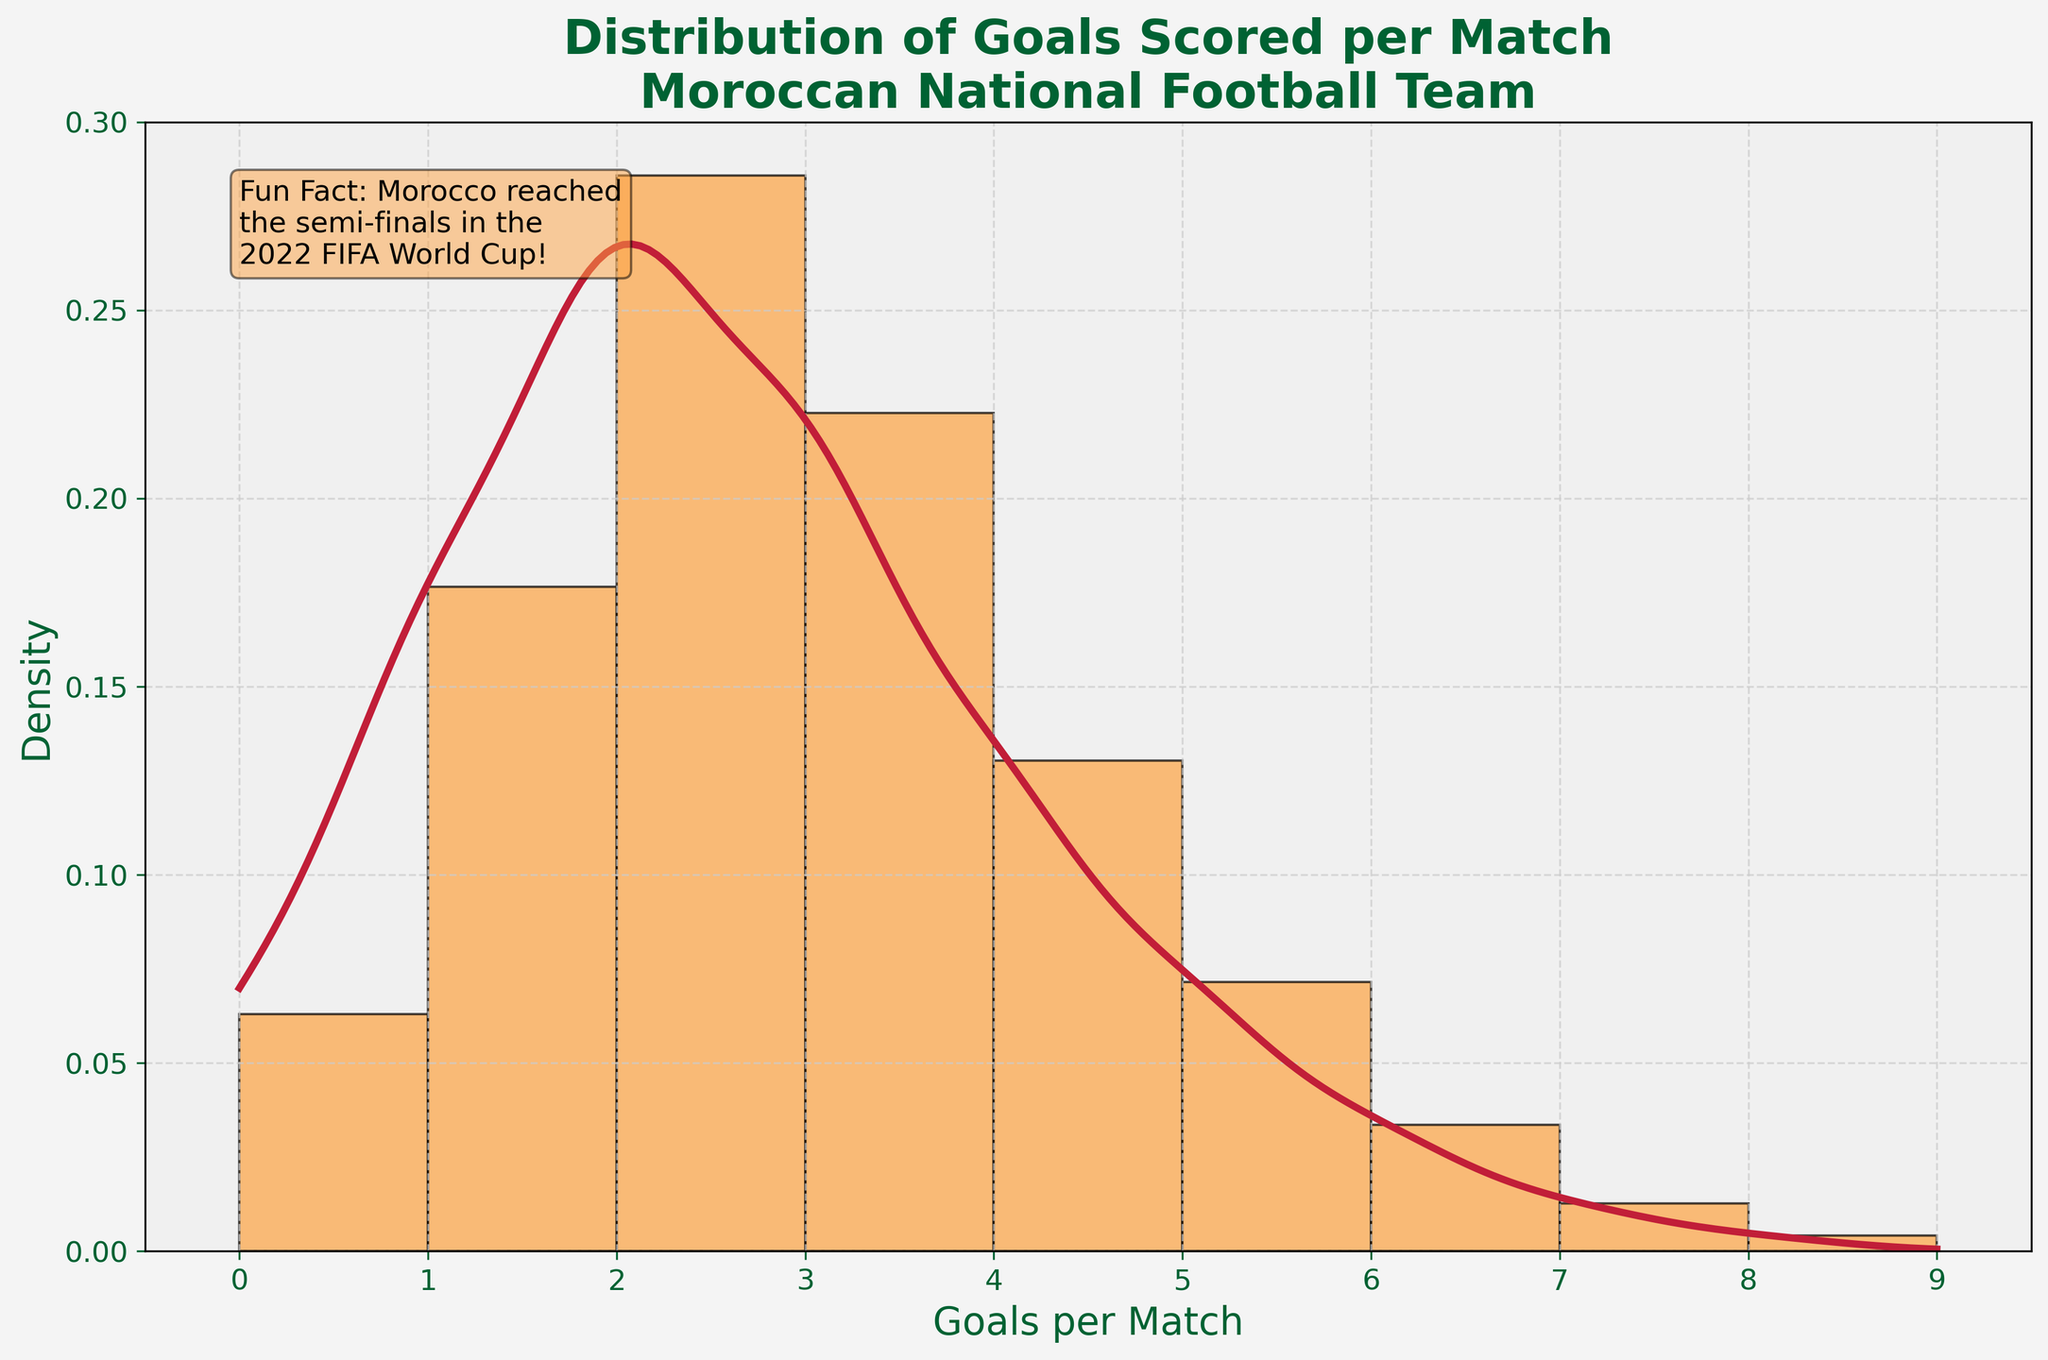What is the title of the histogram? The title of the histogram is prominently displayed at the top and reads 'Distribution of Goals Scored per Match\nMoroccan National Football Team'.
Answer: Distribution of Goals Scored per Match Moroccan National Football Team What does the x-axis represent? The x-axis labels on the horizontal line indicate the number of goals scored per match.
Answer: Goals per Match What does the y-axis represent? The y-axis labels on the vertical line indicate the density, showing the frequency of occurrences of goals scored per match in the Moroccan national football team's history.
Answer: Density Which number of goals scored per match is the most frequent? The highest bar in the histogram represents the most frequent number of goals scored per match. It corresponds to the value 2 on the x-axis.
Answer: 2 What can you infer about matches where Morocco scored 8 goals? The histogram's bar height for 8 goals per match is quite low compared to other bars, indicating that scoring 8 goals in a match is very rare for the Moroccan team.
Answer: Rare How many goals are most common for Morocco to score in a match based on the KDE curve? The peak of the KDE curve shows the highest density around 2 goals, indicating that 2 goals per match is the most common.
Answer: 2 Are matches where Morocco scored no goals more frequent than matches where they scored 5 goals? By comparing the heights of the histogram bars at 0 and 5 goals, we see that the bar at 0 is higher than the bar at 5 goals, indicating matches with no goals are more frequent.
Answer: Yes What's the total number of matches included in this histogram? Adding up all the frequencies from each bar will give the total number of matches: 15 + 42 + 68 + 53 + 31 + 17 + 8 + 3 + 1 = 238.
Answer: 238 In how many matches did Morocco score more than 4 goals? Summing the frequencies for goals greater than 4 (5, 6, 7, 8): 17 + 8 + 3 + 1 = 29.
Answer: 29 What is the overall trend of goal-scoring frequency as the number of goals increases? The histogram shows that as the number of goals increases, the frequency generally decreases, with the highest frequency at 2 goals and tapering off gradually.
Answer: Decreasing 